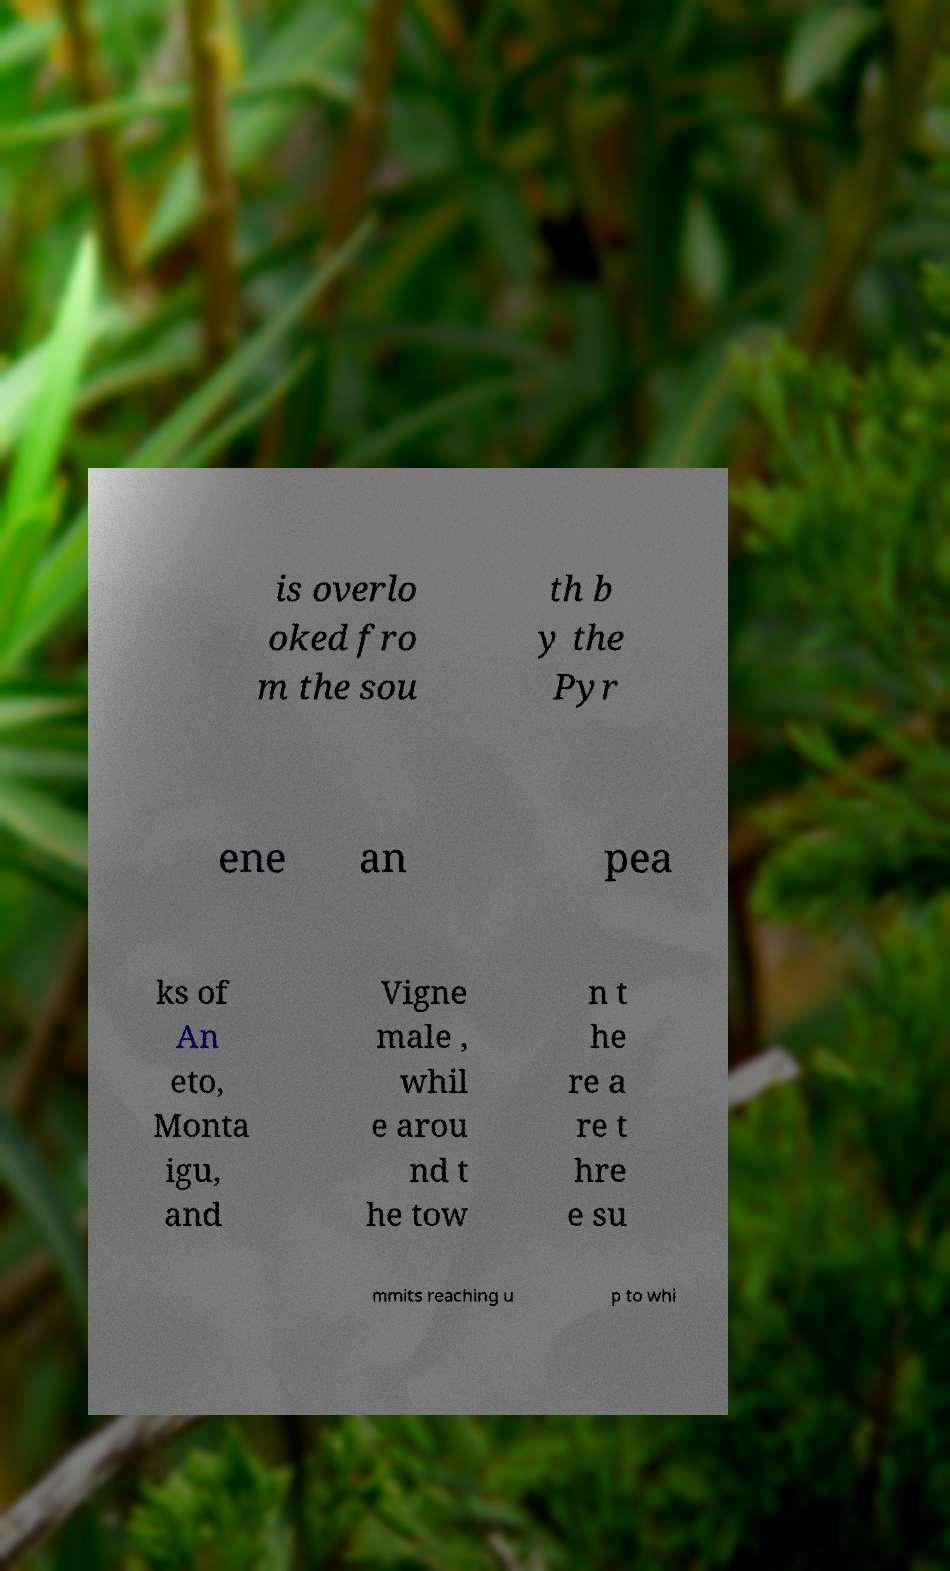Can you read and provide the text displayed in the image?This photo seems to have some interesting text. Can you extract and type it out for me? is overlo oked fro m the sou th b y the Pyr ene an pea ks of An eto, Monta igu, and Vigne male , whil e arou nd t he tow n t he re a re t hre e su mmits reaching u p to whi 